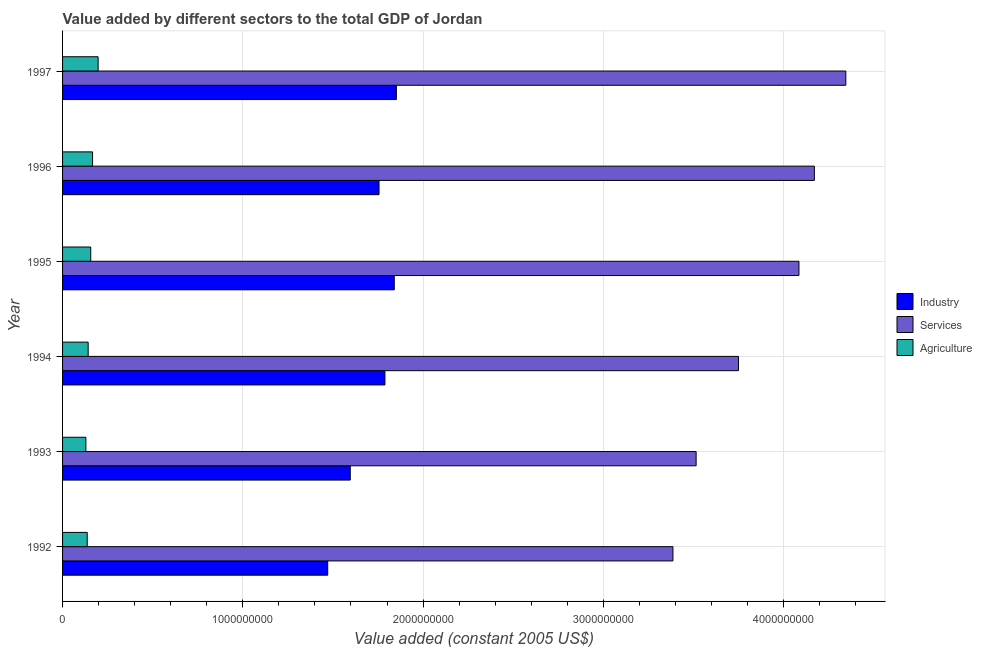How many different coloured bars are there?
Offer a terse response. 3. How many bars are there on the 3rd tick from the top?
Ensure brevity in your answer.  3. In how many cases, is the number of bars for a given year not equal to the number of legend labels?
Your answer should be compact. 0. What is the value added by services in 1993?
Make the answer very short. 3.51e+09. Across all years, what is the maximum value added by agricultural sector?
Offer a terse response. 1.97e+08. Across all years, what is the minimum value added by agricultural sector?
Your answer should be very brief. 1.29e+08. In which year was the value added by agricultural sector maximum?
Give a very brief answer. 1997. In which year was the value added by services minimum?
Ensure brevity in your answer.  1992. What is the total value added by industrial sector in the graph?
Ensure brevity in your answer.  1.03e+1. What is the difference between the value added by industrial sector in 1993 and that in 1995?
Provide a short and direct response. -2.44e+08. What is the difference between the value added by services in 1995 and the value added by industrial sector in 1993?
Provide a succinct answer. 2.49e+09. What is the average value added by agricultural sector per year?
Offer a terse response. 1.55e+08. In the year 1996, what is the difference between the value added by industrial sector and value added by agricultural sector?
Your response must be concise. 1.59e+09. Is the value added by services in 1992 less than that in 1993?
Offer a very short reply. Yes. Is the difference between the value added by services in 1992 and 1995 greater than the difference between the value added by industrial sector in 1992 and 1995?
Offer a terse response. No. What is the difference between the highest and the second highest value added by agricultural sector?
Your answer should be very brief. 3.08e+07. What is the difference between the highest and the lowest value added by industrial sector?
Ensure brevity in your answer.  3.81e+08. In how many years, is the value added by services greater than the average value added by services taken over all years?
Provide a succinct answer. 3. Is the sum of the value added by services in 1993 and 1997 greater than the maximum value added by industrial sector across all years?
Your response must be concise. Yes. What does the 2nd bar from the top in 1995 represents?
Offer a terse response. Services. What does the 2nd bar from the bottom in 1994 represents?
Your response must be concise. Services. Is it the case that in every year, the sum of the value added by industrial sector and value added by services is greater than the value added by agricultural sector?
Your answer should be compact. Yes. How many bars are there?
Your response must be concise. 18. Are all the bars in the graph horizontal?
Provide a short and direct response. Yes. What is the difference between two consecutive major ticks on the X-axis?
Your response must be concise. 1.00e+09. Are the values on the major ticks of X-axis written in scientific E-notation?
Your response must be concise. No. Does the graph contain any zero values?
Offer a very short reply. No. Does the graph contain grids?
Keep it short and to the point. Yes. Where does the legend appear in the graph?
Give a very brief answer. Center right. What is the title of the graph?
Give a very brief answer. Value added by different sectors to the total GDP of Jordan. What is the label or title of the X-axis?
Ensure brevity in your answer.  Value added (constant 2005 US$). What is the label or title of the Y-axis?
Offer a very short reply. Year. What is the Value added (constant 2005 US$) in Industry in 1992?
Give a very brief answer. 1.47e+09. What is the Value added (constant 2005 US$) in Services in 1992?
Offer a very short reply. 3.39e+09. What is the Value added (constant 2005 US$) of Agriculture in 1992?
Ensure brevity in your answer.  1.37e+08. What is the Value added (constant 2005 US$) of Industry in 1993?
Keep it short and to the point. 1.60e+09. What is the Value added (constant 2005 US$) in Services in 1993?
Ensure brevity in your answer.  3.51e+09. What is the Value added (constant 2005 US$) in Agriculture in 1993?
Offer a very short reply. 1.29e+08. What is the Value added (constant 2005 US$) of Industry in 1994?
Offer a terse response. 1.79e+09. What is the Value added (constant 2005 US$) in Services in 1994?
Your answer should be very brief. 3.75e+09. What is the Value added (constant 2005 US$) in Agriculture in 1994?
Your response must be concise. 1.42e+08. What is the Value added (constant 2005 US$) of Industry in 1995?
Provide a short and direct response. 1.84e+09. What is the Value added (constant 2005 US$) of Services in 1995?
Your answer should be compact. 4.09e+09. What is the Value added (constant 2005 US$) of Agriculture in 1995?
Provide a succinct answer. 1.56e+08. What is the Value added (constant 2005 US$) in Industry in 1996?
Keep it short and to the point. 1.76e+09. What is the Value added (constant 2005 US$) of Services in 1996?
Provide a succinct answer. 4.17e+09. What is the Value added (constant 2005 US$) in Agriculture in 1996?
Your answer should be compact. 1.66e+08. What is the Value added (constant 2005 US$) in Industry in 1997?
Ensure brevity in your answer.  1.85e+09. What is the Value added (constant 2005 US$) of Services in 1997?
Give a very brief answer. 4.35e+09. What is the Value added (constant 2005 US$) of Agriculture in 1997?
Keep it short and to the point. 1.97e+08. Across all years, what is the maximum Value added (constant 2005 US$) of Industry?
Provide a succinct answer. 1.85e+09. Across all years, what is the maximum Value added (constant 2005 US$) in Services?
Your response must be concise. 4.35e+09. Across all years, what is the maximum Value added (constant 2005 US$) in Agriculture?
Your response must be concise. 1.97e+08. Across all years, what is the minimum Value added (constant 2005 US$) in Industry?
Offer a terse response. 1.47e+09. Across all years, what is the minimum Value added (constant 2005 US$) of Services?
Keep it short and to the point. 3.39e+09. Across all years, what is the minimum Value added (constant 2005 US$) of Agriculture?
Make the answer very short. 1.29e+08. What is the total Value added (constant 2005 US$) in Industry in the graph?
Keep it short and to the point. 1.03e+1. What is the total Value added (constant 2005 US$) of Services in the graph?
Offer a very short reply. 2.33e+1. What is the total Value added (constant 2005 US$) of Agriculture in the graph?
Your answer should be compact. 9.28e+08. What is the difference between the Value added (constant 2005 US$) of Industry in 1992 and that in 1993?
Give a very brief answer. -1.25e+08. What is the difference between the Value added (constant 2005 US$) of Services in 1992 and that in 1993?
Ensure brevity in your answer.  -1.29e+08. What is the difference between the Value added (constant 2005 US$) in Agriculture in 1992 and that in 1993?
Your answer should be very brief. 7.44e+06. What is the difference between the Value added (constant 2005 US$) in Industry in 1992 and that in 1994?
Keep it short and to the point. -3.17e+08. What is the difference between the Value added (constant 2005 US$) of Services in 1992 and that in 1994?
Your response must be concise. -3.64e+08. What is the difference between the Value added (constant 2005 US$) in Agriculture in 1992 and that in 1994?
Make the answer very short. -5.25e+06. What is the difference between the Value added (constant 2005 US$) of Industry in 1992 and that in 1995?
Your response must be concise. -3.69e+08. What is the difference between the Value added (constant 2005 US$) of Services in 1992 and that in 1995?
Offer a terse response. -6.99e+08. What is the difference between the Value added (constant 2005 US$) of Agriculture in 1992 and that in 1995?
Provide a short and direct response. -1.95e+07. What is the difference between the Value added (constant 2005 US$) of Industry in 1992 and that in 1996?
Offer a terse response. -2.85e+08. What is the difference between the Value added (constant 2005 US$) in Services in 1992 and that in 1996?
Provide a succinct answer. -7.85e+08. What is the difference between the Value added (constant 2005 US$) of Agriculture in 1992 and that in 1996?
Your answer should be compact. -2.96e+07. What is the difference between the Value added (constant 2005 US$) in Industry in 1992 and that in 1997?
Your response must be concise. -3.81e+08. What is the difference between the Value added (constant 2005 US$) of Services in 1992 and that in 1997?
Your answer should be very brief. -9.59e+08. What is the difference between the Value added (constant 2005 US$) in Agriculture in 1992 and that in 1997?
Your response must be concise. -6.05e+07. What is the difference between the Value added (constant 2005 US$) of Industry in 1993 and that in 1994?
Ensure brevity in your answer.  -1.92e+08. What is the difference between the Value added (constant 2005 US$) of Services in 1993 and that in 1994?
Keep it short and to the point. -2.35e+08. What is the difference between the Value added (constant 2005 US$) of Agriculture in 1993 and that in 1994?
Ensure brevity in your answer.  -1.27e+07. What is the difference between the Value added (constant 2005 US$) in Industry in 1993 and that in 1995?
Provide a short and direct response. -2.44e+08. What is the difference between the Value added (constant 2005 US$) in Services in 1993 and that in 1995?
Your answer should be very brief. -5.70e+08. What is the difference between the Value added (constant 2005 US$) of Agriculture in 1993 and that in 1995?
Provide a succinct answer. -2.69e+07. What is the difference between the Value added (constant 2005 US$) in Industry in 1993 and that in 1996?
Your answer should be very brief. -1.60e+08. What is the difference between the Value added (constant 2005 US$) in Services in 1993 and that in 1996?
Provide a succinct answer. -6.56e+08. What is the difference between the Value added (constant 2005 US$) in Agriculture in 1993 and that in 1996?
Your answer should be very brief. -3.71e+07. What is the difference between the Value added (constant 2005 US$) in Industry in 1993 and that in 1997?
Provide a short and direct response. -2.56e+08. What is the difference between the Value added (constant 2005 US$) of Services in 1993 and that in 1997?
Give a very brief answer. -8.30e+08. What is the difference between the Value added (constant 2005 US$) of Agriculture in 1993 and that in 1997?
Offer a terse response. -6.79e+07. What is the difference between the Value added (constant 2005 US$) in Industry in 1994 and that in 1995?
Make the answer very short. -5.17e+07. What is the difference between the Value added (constant 2005 US$) in Services in 1994 and that in 1995?
Provide a succinct answer. -3.35e+08. What is the difference between the Value added (constant 2005 US$) of Agriculture in 1994 and that in 1995?
Offer a very short reply. -1.42e+07. What is the difference between the Value added (constant 2005 US$) in Industry in 1994 and that in 1996?
Provide a short and direct response. 3.27e+07. What is the difference between the Value added (constant 2005 US$) of Services in 1994 and that in 1996?
Provide a succinct answer. -4.21e+08. What is the difference between the Value added (constant 2005 US$) in Agriculture in 1994 and that in 1996?
Your answer should be very brief. -2.44e+07. What is the difference between the Value added (constant 2005 US$) in Industry in 1994 and that in 1997?
Give a very brief answer. -6.34e+07. What is the difference between the Value added (constant 2005 US$) in Services in 1994 and that in 1997?
Your answer should be compact. -5.96e+08. What is the difference between the Value added (constant 2005 US$) in Agriculture in 1994 and that in 1997?
Provide a succinct answer. -5.52e+07. What is the difference between the Value added (constant 2005 US$) of Industry in 1995 and that in 1996?
Provide a succinct answer. 8.45e+07. What is the difference between the Value added (constant 2005 US$) in Services in 1995 and that in 1996?
Ensure brevity in your answer.  -8.55e+07. What is the difference between the Value added (constant 2005 US$) of Agriculture in 1995 and that in 1996?
Your response must be concise. -1.02e+07. What is the difference between the Value added (constant 2005 US$) in Industry in 1995 and that in 1997?
Provide a short and direct response. -1.16e+07. What is the difference between the Value added (constant 2005 US$) of Services in 1995 and that in 1997?
Ensure brevity in your answer.  -2.60e+08. What is the difference between the Value added (constant 2005 US$) in Agriculture in 1995 and that in 1997?
Keep it short and to the point. -4.10e+07. What is the difference between the Value added (constant 2005 US$) in Industry in 1996 and that in 1997?
Offer a terse response. -9.61e+07. What is the difference between the Value added (constant 2005 US$) in Services in 1996 and that in 1997?
Offer a terse response. -1.75e+08. What is the difference between the Value added (constant 2005 US$) in Agriculture in 1996 and that in 1997?
Your answer should be compact. -3.08e+07. What is the difference between the Value added (constant 2005 US$) in Industry in 1992 and the Value added (constant 2005 US$) in Services in 1993?
Make the answer very short. -2.04e+09. What is the difference between the Value added (constant 2005 US$) of Industry in 1992 and the Value added (constant 2005 US$) of Agriculture in 1993?
Offer a terse response. 1.34e+09. What is the difference between the Value added (constant 2005 US$) in Services in 1992 and the Value added (constant 2005 US$) in Agriculture in 1993?
Offer a terse response. 3.26e+09. What is the difference between the Value added (constant 2005 US$) in Industry in 1992 and the Value added (constant 2005 US$) in Services in 1994?
Make the answer very short. -2.28e+09. What is the difference between the Value added (constant 2005 US$) of Industry in 1992 and the Value added (constant 2005 US$) of Agriculture in 1994?
Provide a succinct answer. 1.33e+09. What is the difference between the Value added (constant 2005 US$) of Services in 1992 and the Value added (constant 2005 US$) of Agriculture in 1994?
Keep it short and to the point. 3.24e+09. What is the difference between the Value added (constant 2005 US$) in Industry in 1992 and the Value added (constant 2005 US$) in Services in 1995?
Provide a succinct answer. -2.61e+09. What is the difference between the Value added (constant 2005 US$) of Industry in 1992 and the Value added (constant 2005 US$) of Agriculture in 1995?
Make the answer very short. 1.31e+09. What is the difference between the Value added (constant 2005 US$) in Services in 1992 and the Value added (constant 2005 US$) in Agriculture in 1995?
Your response must be concise. 3.23e+09. What is the difference between the Value added (constant 2005 US$) in Industry in 1992 and the Value added (constant 2005 US$) in Services in 1996?
Ensure brevity in your answer.  -2.70e+09. What is the difference between the Value added (constant 2005 US$) in Industry in 1992 and the Value added (constant 2005 US$) in Agriculture in 1996?
Give a very brief answer. 1.30e+09. What is the difference between the Value added (constant 2005 US$) in Services in 1992 and the Value added (constant 2005 US$) in Agriculture in 1996?
Your response must be concise. 3.22e+09. What is the difference between the Value added (constant 2005 US$) of Industry in 1992 and the Value added (constant 2005 US$) of Services in 1997?
Offer a very short reply. -2.87e+09. What is the difference between the Value added (constant 2005 US$) in Industry in 1992 and the Value added (constant 2005 US$) in Agriculture in 1997?
Offer a terse response. 1.27e+09. What is the difference between the Value added (constant 2005 US$) of Services in 1992 and the Value added (constant 2005 US$) of Agriculture in 1997?
Your answer should be very brief. 3.19e+09. What is the difference between the Value added (constant 2005 US$) of Industry in 1993 and the Value added (constant 2005 US$) of Services in 1994?
Your answer should be compact. -2.15e+09. What is the difference between the Value added (constant 2005 US$) in Industry in 1993 and the Value added (constant 2005 US$) in Agriculture in 1994?
Offer a terse response. 1.45e+09. What is the difference between the Value added (constant 2005 US$) in Services in 1993 and the Value added (constant 2005 US$) in Agriculture in 1994?
Make the answer very short. 3.37e+09. What is the difference between the Value added (constant 2005 US$) in Industry in 1993 and the Value added (constant 2005 US$) in Services in 1995?
Offer a terse response. -2.49e+09. What is the difference between the Value added (constant 2005 US$) in Industry in 1993 and the Value added (constant 2005 US$) in Agriculture in 1995?
Ensure brevity in your answer.  1.44e+09. What is the difference between the Value added (constant 2005 US$) of Services in 1993 and the Value added (constant 2005 US$) of Agriculture in 1995?
Ensure brevity in your answer.  3.36e+09. What is the difference between the Value added (constant 2005 US$) of Industry in 1993 and the Value added (constant 2005 US$) of Services in 1996?
Make the answer very short. -2.57e+09. What is the difference between the Value added (constant 2005 US$) in Industry in 1993 and the Value added (constant 2005 US$) in Agriculture in 1996?
Keep it short and to the point. 1.43e+09. What is the difference between the Value added (constant 2005 US$) in Services in 1993 and the Value added (constant 2005 US$) in Agriculture in 1996?
Your response must be concise. 3.35e+09. What is the difference between the Value added (constant 2005 US$) in Industry in 1993 and the Value added (constant 2005 US$) in Services in 1997?
Offer a very short reply. -2.75e+09. What is the difference between the Value added (constant 2005 US$) in Industry in 1993 and the Value added (constant 2005 US$) in Agriculture in 1997?
Give a very brief answer. 1.40e+09. What is the difference between the Value added (constant 2005 US$) in Services in 1993 and the Value added (constant 2005 US$) in Agriculture in 1997?
Your response must be concise. 3.32e+09. What is the difference between the Value added (constant 2005 US$) in Industry in 1994 and the Value added (constant 2005 US$) in Services in 1995?
Your response must be concise. -2.30e+09. What is the difference between the Value added (constant 2005 US$) of Industry in 1994 and the Value added (constant 2005 US$) of Agriculture in 1995?
Your answer should be compact. 1.63e+09. What is the difference between the Value added (constant 2005 US$) in Services in 1994 and the Value added (constant 2005 US$) in Agriculture in 1995?
Provide a short and direct response. 3.59e+09. What is the difference between the Value added (constant 2005 US$) of Industry in 1994 and the Value added (constant 2005 US$) of Services in 1996?
Make the answer very short. -2.38e+09. What is the difference between the Value added (constant 2005 US$) of Industry in 1994 and the Value added (constant 2005 US$) of Agriculture in 1996?
Provide a succinct answer. 1.62e+09. What is the difference between the Value added (constant 2005 US$) of Services in 1994 and the Value added (constant 2005 US$) of Agriculture in 1996?
Give a very brief answer. 3.58e+09. What is the difference between the Value added (constant 2005 US$) of Industry in 1994 and the Value added (constant 2005 US$) of Services in 1997?
Give a very brief answer. -2.56e+09. What is the difference between the Value added (constant 2005 US$) in Industry in 1994 and the Value added (constant 2005 US$) in Agriculture in 1997?
Provide a succinct answer. 1.59e+09. What is the difference between the Value added (constant 2005 US$) in Services in 1994 and the Value added (constant 2005 US$) in Agriculture in 1997?
Keep it short and to the point. 3.55e+09. What is the difference between the Value added (constant 2005 US$) in Industry in 1995 and the Value added (constant 2005 US$) in Services in 1996?
Provide a succinct answer. -2.33e+09. What is the difference between the Value added (constant 2005 US$) of Industry in 1995 and the Value added (constant 2005 US$) of Agriculture in 1996?
Ensure brevity in your answer.  1.67e+09. What is the difference between the Value added (constant 2005 US$) in Services in 1995 and the Value added (constant 2005 US$) in Agriculture in 1996?
Give a very brief answer. 3.92e+09. What is the difference between the Value added (constant 2005 US$) of Industry in 1995 and the Value added (constant 2005 US$) of Services in 1997?
Provide a succinct answer. -2.51e+09. What is the difference between the Value added (constant 2005 US$) of Industry in 1995 and the Value added (constant 2005 US$) of Agriculture in 1997?
Provide a succinct answer. 1.64e+09. What is the difference between the Value added (constant 2005 US$) of Services in 1995 and the Value added (constant 2005 US$) of Agriculture in 1997?
Keep it short and to the point. 3.89e+09. What is the difference between the Value added (constant 2005 US$) of Industry in 1996 and the Value added (constant 2005 US$) of Services in 1997?
Keep it short and to the point. -2.59e+09. What is the difference between the Value added (constant 2005 US$) in Industry in 1996 and the Value added (constant 2005 US$) in Agriculture in 1997?
Your response must be concise. 1.56e+09. What is the difference between the Value added (constant 2005 US$) of Services in 1996 and the Value added (constant 2005 US$) of Agriculture in 1997?
Your answer should be compact. 3.97e+09. What is the average Value added (constant 2005 US$) in Industry per year?
Ensure brevity in your answer.  1.72e+09. What is the average Value added (constant 2005 US$) of Services per year?
Offer a terse response. 3.88e+09. What is the average Value added (constant 2005 US$) of Agriculture per year?
Give a very brief answer. 1.55e+08. In the year 1992, what is the difference between the Value added (constant 2005 US$) in Industry and Value added (constant 2005 US$) in Services?
Make the answer very short. -1.92e+09. In the year 1992, what is the difference between the Value added (constant 2005 US$) of Industry and Value added (constant 2005 US$) of Agriculture?
Your answer should be very brief. 1.33e+09. In the year 1992, what is the difference between the Value added (constant 2005 US$) of Services and Value added (constant 2005 US$) of Agriculture?
Offer a terse response. 3.25e+09. In the year 1993, what is the difference between the Value added (constant 2005 US$) of Industry and Value added (constant 2005 US$) of Services?
Offer a very short reply. -1.92e+09. In the year 1993, what is the difference between the Value added (constant 2005 US$) of Industry and Value added (constant 2005 US$) of Agriculture?
Offer a very short reply. 1.47e+09. In the year 1993, what is the difference between the Value added (constant 2005 US$) of Services and Value added (constant 2005 US$) of Agriculture?
Your answer should be compact. 3.39e+09. In the year 1994, what is the difference between the Value added (constant 2005 US$) in Industry and Value added (constant 2005 US$) in Services?
Give a very brief answer. -1.96e+09. In the year 1994, what is the difference between the Value added (constant 2005 US$) of Industry and Value added (constant 2005 US$) of Agriculture?
Provide a succinct answer. 1.65e+09. In the year 1994, what is the difference between the Value added (constant 2005 US$) in Services and Value added (constant 2005 US$) in Agriculture?
Offer a very short reply. 3.61e+09. In the year 1995, what is the difference between the Value added (constant 2005 US$) of Industry and Value added (constant 2005 US$) of Services?
Ensure brevity in your answer.  -2.25e+09. In the year 1995, what is the difference between the Value added (constant 2005 US$) of Industry and Value added (constant 2005 US$) of Agriculture?
Your answer should be compact. 1.68e+09. In the year 1995, what is the difference between the Value added (constant 2005 US$) of Services and Value added (constant 2005 US$) of Agriculture?
Keep it short and to the point. 3.93e+09. In the year 1996, what is the difference between the Value added (constant 2005 US$) in Industry and Value added (constant 2005 US$) in Services?
Ensure brevity in your answer.  -2.42e+09. In the year 1996, what is the difference between the Value added (constant 2005 US$) of Industry and Value added (constant 2005 US$) of Agriculture?
Your answer should be compact. 1.59e+09. In the year 1996, what is the difference between the Value added (constant 2005 US$) of Services and Value added (constant 2005 US$) of Agriculture?
Provide a succinct answer. 4.00e+09. In the year 1997, what is the difference between the Value added (constant 2005 US$) of Industry and Value added (constant 2005 US$) of Services?
Your response must be concise. -2.49e+09. In the year 1997, what is the difference between the Value added (constant 2005 US$) of Industry and Value added (constant 2005 US$) of Agriculture?
Ensure brevity in your answer.  1.65e+09. In the year 1997, what is the difference between the Value added (constant 2005 US$) of Services and Value added (constant 2005 US$) of Agriculture?
Ensure brevity in your answer.  4.15e+09. What is the ratio of the Value added (constant 2005 US$) of Industry in 1992 to that in 1993?
Offer a terse response. 0.92. What is the ratio of the Value added (constant 2005 US$) of Services in 1992 to that in 1993?
Provide a succinct answer. 0.96. What is the ratio of the Value added (constant 2005 US$) in Agriculture in 1992 to that in 1993?
Make the answer very short. 1.06. What is the ratio of the Value added (constant 2005 US$) of Industry in 1992 to that in 1994?
Provide a short and direct response. 0.82. What is the ratio of the Value added (constant 2005 US$) in Services in 1992 to that in 1994?
Your answer should be very brief. 0.9. What is the ratio of the Value added (constant 2005 US$) in Industry in 1992 to that in 1995?
Your answer should be compact. 0.8. What is the ratio of the Value added (constant 2005 US$) in Services in 1992 to that in 1995?
Offer a terse response. 0.83. What is the ratio of the Value added (constant 2005 US$) in Agriculture in 1992 to that in 1995?
Make the answer very short. 0.88. What is the ratio of the Value added (constant 2005 US$) of Industry in 1992 to that in 1996?
Make the answer very short. 0.84. What is the ratio of the Value added (constant 2005 US$) in Services in 1992 to that in 1996?
Ensure brevity in your answer.  0.81. What is the ratio of the Value added (constant 2005 US$) of Agriculture in 1992 to that in 1996?
Provide a short and direct response. 0.82. What is the ratio of the Value added (constant 2005 US$) of Industry in 1992 to that in 1997?
Your response must be concise. 0.79. What is the ratio of the Value added (constant 2005 US$) in Services in 1992 to that in 1997?
Your answer should be very brief. 0.78. What is the ratio of the Value added (constant 2005 US$) in Agriculture in 1992 to that in 1997?
Ensure brevity in your answer.  0.69. What is the ratio of the Value added (constant 2005 US$) of Industry in 1993 to that in 1994?
Offer a very short reply. 0.89. What is the ratio of the Value added (constant 2005 US$) of Services in 1993 to that in 1994?
Make the answer very short. 0.94. What is the ratio of the Value added (constant 2005 US$) in Agriculture in 1993 to that in 1994?
Ensure brevity in your answer.  0.91. What is the ratio of the Value added (constant 2005 US$) of Industry in 1993 to that in 1995?
Keep it short and to the point. 0.87. What is the ratio of the Value added (constant 2005 US$) of Services in 1993 to that in 1995?
Ensure brevity in your answer.  0.86. What is the ratio of the Value added (constant 2005 US$) of Agriculture in 1993 to that in 1995?
Keep it short and to the point. 0.83. What is the ratio of the Value added (constant 2005 US$) of Services in 1993 to that in 1996?
Make the answer very short. 0.84. What is the ratio of the Value added (constant 2005 US$) of Agriculture in 1993 to that in 1996?
Ensure brevity in your answer.  0.78. What is the ratio of the Value added (constant 2005 US$) of Industry in 1993 to that in 1997?
Your response must be concise. 0.86. What is the ratio of the Value added (constant 2005 US$) of Services in 1993 to that in 1997?
Keep it short and to the point. 0.81. What is the ratio of the Value added (constant 2005 US$) of Agriculture in 1993 to that in 1997?
Provide a short and direct response. 0.66. What is the ratio of the Value added (constant 2005 US$) of Industry in 1994 to that in 1995?
Provide a succinct answer. 0.97. What is the ratio of the Value added (constant 2005 US$) of Services in 1994 to that in 1995?
Provide a short and direct response. 0.92. What is the ratio of the Value added (constant 2005 US$) in Agriculture in 1994 to that in 1995?
Ensure brevity in your answer.  0.91. What is the ratio of the Value added (constant 2005 US$) of Industry in 1994 to that in 1996?
Keep it short and to the point. 1.02. What is the ratio of the Value added (constant 2005 US$) in Services in 1994 to that in 1996?
Keep it short and to the point. 0.9. What is the ratio of the Value added (constant 2005 US$) in Agriculture in 1994 to that in 1996?
Provide a short and direct response. 0.85. What is the ratio of the Value added (constant 2005 US$) in Industry in 1994 to that in 1997?
Offer a very short reply. 0.97. What is the ratio of the Value added (constant 2005 US$) of Services in 1994 to that in 1997?
Your response must be concise. 0.86. What is the ratio of the Value added (constant 2005 US$) in Agriculture in 1994 to that in 1997?
Your answer should be compact. 0.72. What is the ratio of the Value added (constant 2005 US$) of Industry in 1995 to that in 1996?
Your answer should be very brief. 1.05. What is the ratio of the Value added (constant 2005 US$) in Services in 1995 to that in 1996?
Your answer should be very brief. 0.98. What is the ratio of the Value added (constant 2005 US$) in Agriculture in 1995 to that in 1996?
Your response must be concise. 0.94. What is the ratio of the Value added (constant 2005 US$) in Industry in 1995 to that in 1997?
Your answer should be very brief. 0.99. What is the ratio of the Value added (constant 2005 US$) in Services in 1995 to that in 1997?
Ensure brevity in your answer.  0.94. What is the ratio of the Value added (constant 2005 US$) in Agriculture in 1995 to that in 1997?
Make the answer very short. 0.79. What is the ratio of the Value added (constant 2005 US$) of Industry in 1996 to that in 1997?
Your answer should be very brief. 0.95. What is the ratio of the Value added (constant 2005 US$) in Services in 1996 to that in 1997?
Provide a succinct answer. 0.96. What is the ratio of the Value added (constant 2005 US$) of Agriculture in 1996 to that in 1997?
Give a very brief answer. 0.84. What is the difference between the highest and the second highest Value added (constant 2005 US$) of Industry?
Ensure brevity in your answer.  1.16e+07. What is the difference between the highest and the second highest Value added (constant 2005 US$) in Services?
Make the answer very short. 1.75e+08. What is the difference between the highest and the second highest Value added (constant 2005 US$) in Agriculture?
Give a very brief answer. 3.08e+07. What is the difference between the highest and the lowest Value added (constant 2005 US$) of Industry?
Keep it short and to the point. 3.81e+08. What is the difference between the highest and the lowest Value added (constant 2005 US$) of Services?
Keep it short and to the point. 9.59e+08. What is the difference between the highest and the lowest Value added (constant 2005 US$) in Agriculture?
Keep it short and to the point. 6.79e+07. 